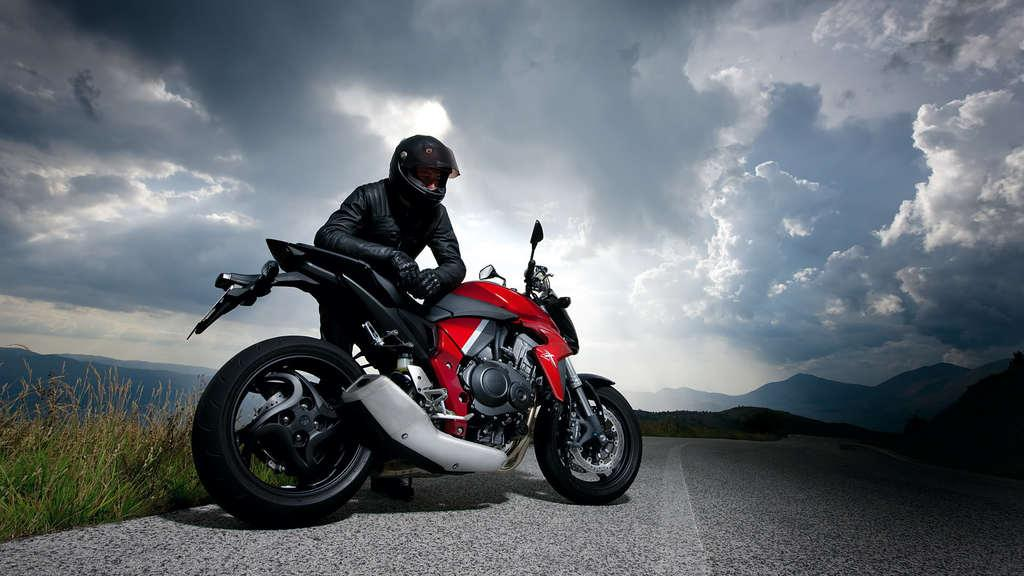What is the main subject of the image? The main subject of the image is a motorbike. Who or what is near the motorbike? A person is standing beside the motorbike. What is the person wearing? The person is wearing a helmet. What can be seen in the background of the image? There are mountains, grass, and a cloudy sky visible in the background of the image. What type of vegetable is being used as a decoration on the motorbike? There is no vegetable present on the motorbike in the image. Who is the friend standing beside the motorbike? There is no friend visible in the image; only one person is standing beside the motorbike. 